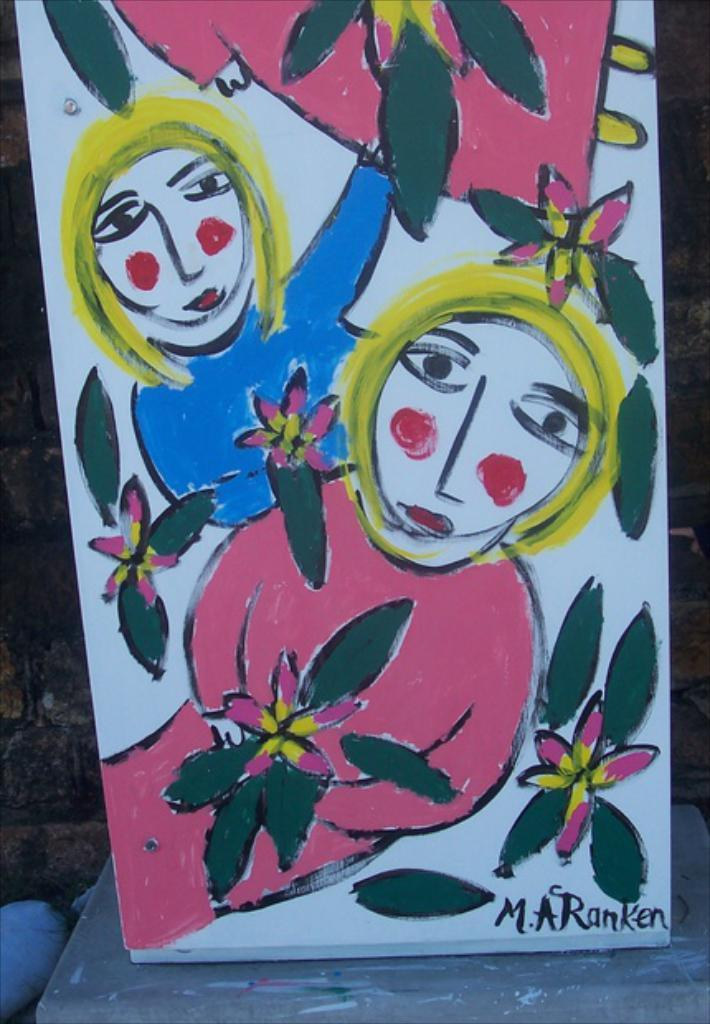What is depicted on the board in the image? There is a painting on a board in the image. What subjects are included in the painting? The painting contains persons and flowers. What type of instrument is being used to make the payment for the painting in the image? There is no payment or instrument present in the image; it only shows a painting on a board. 